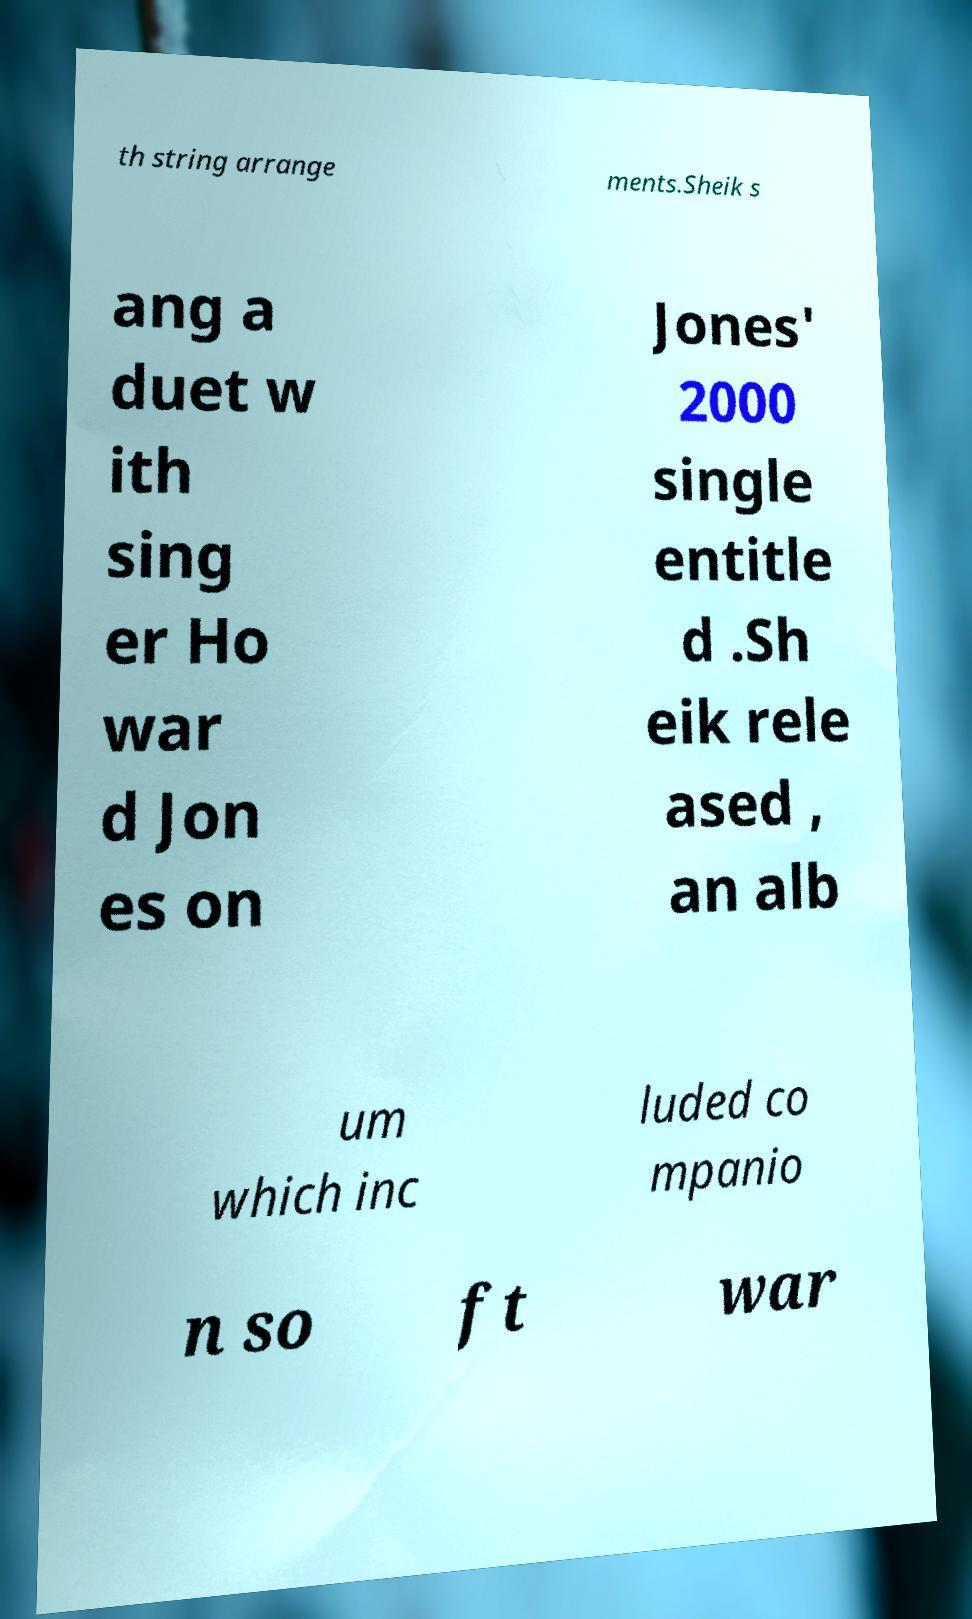What messages or text are displayed in this image? I need them in a readable, typed format. th string arrange ments.Sheik s ang a duet w ith sing er Ho war d Jon es on Jones' 2000 single entitle d .Sh eik rele ased , an alb um which inc luded co mpanio n so ft war 